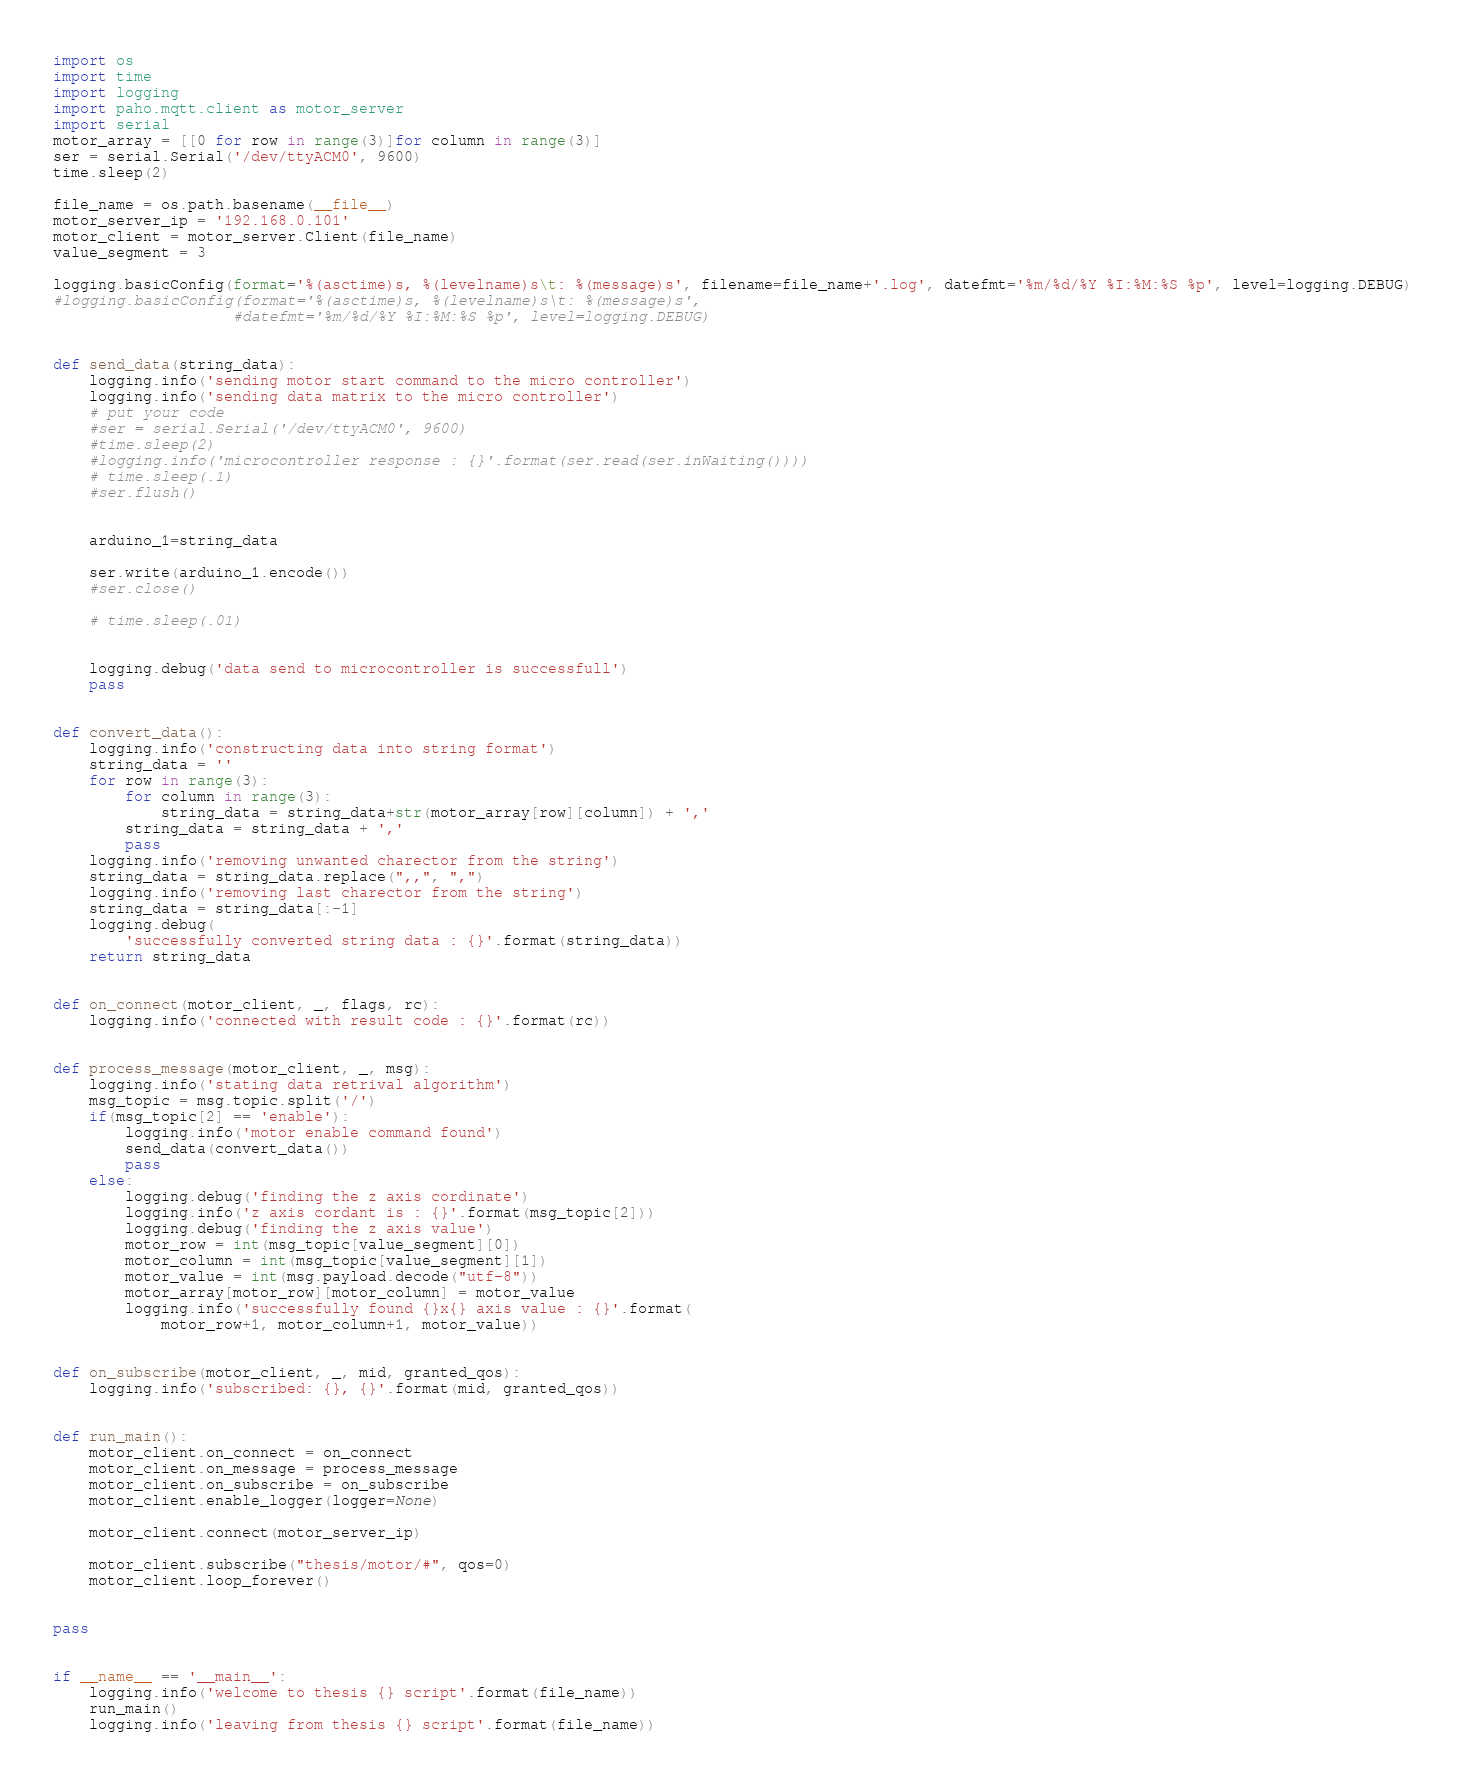<code> <loc_0><loc_0><loc_500><loc_500><_Python_>import os
import time
import logging
import paho.mqtt.client as motor_server
import serial
motor_array = [[0 for row in range(3)]for column in range(3)]
ser = serial.Serial('/dev/ttyACM0', 9600)
time.sleep(2)

file_name = os.path.basename(__file__)
motor_server_ip = '192.168.0.101'
motor_client = motor_server.Client(file_name)
value_segment = 3

logging.basicConfig(format='%(asctime)s, %(levelname)s\t: %(message)s', filename=file_name+'.log', datefmt='%m/%d/%Y %I:%M:%S %p', level=logging.DEBUG)
#logging.basicConfig(format='%(asctime)s, %(levelname)s\t: %(message)s',
                    #datefmt='%m/%d/%Y %I:%M:%S %p', level=logging.DEBUG)


def send_data(string_data):
    logging.info('sending motor start command to the micro controller')
    logging.info('sending data matrix to the micro controller')
    # put your code
    #ser = serial.Serial('/dev/ttyACM0', 9600)
    #time.sleep(2)
    #logging.info('microcontroller response : {}'.format(ser.read(ser.inWaiting())))
    # time.sleep(.1)
    #ser.flush()
    
    
    arduino_1=string_data
    
    ser.write(arduino_1.encode())
    #ser.close()
    
    # time.sleep(.01)
    

    logging.debug('data send to microcontroller is successfull')
    pass


def convert_data():
    logging.info('constructing data into string format')
    string_data = ''
    for row in range(3):
        for column in range(3):
            string_data = string_data+str(motor_array[row][column]) + ','
        string_data = string_data + ','
        pass
    logging.info('removing unwanted charector from the string')
    string_data = string_data.replace(",,", ",")
    logging.info('removing last charector from the string')
    string_data = string_data[:-1]
    logging.debug(
        'successfully converted string data : {}'.format(string_data))
    return string_data


def on_connect(motor_client, _, flags, rc):
    logging.info('connected with result code : {}'.format(rc))


def process_message(motor_client, _, msg):
    logging.info('stating data retrival algorithm')
    msg_topic = msg.topic.split('/')
    if(msg_topic[2] == 'enable'):
        logging.info('motor enable command found')
        send_data(convert_data())
        pass
    else:
        logging.debug('finding the z axis cordinate')
        logging.info('z axis cordant is : {}'.format(msg_topic[2]))
        logging.debug('finding the z axis value')
        motor_row = int(msg_topic[value_segment][0])
        motor_column = int(msg_topic[value_segment][1])
        motor_value = int(msg.payload.decode("utf-8"))
        motor_array[motor_row][motor_column] = motor_value
        logging.info('successfully found {}x{} axis value : {}'.format(
            motor_row+1, motor_column+1, motor_value))


def on_subscribe(motor_client, _, mid, granted_qos):
    logging.info('subscribed: {}, {}'.format(mid, granted_qos))


def run_main():
    motor_client.on_connect = on_connect
    motor_client.on_message = process_message
    motor_client.on_subscribe = on_subscribe
    motor_client.enable_logger(logger=None)

    motor_client.connect(motor_server_ip)

    motor_client.subscribe("thesis/motor/#", qos=0)
    motor_client.loop_forever()


pass


if __name__ == '__main__':
    logging.info('welcome to thesis {} script'.format(file_name))
    run_main()
    logging.info('leaving from thesis {} script'.format(file_name))
</code> 